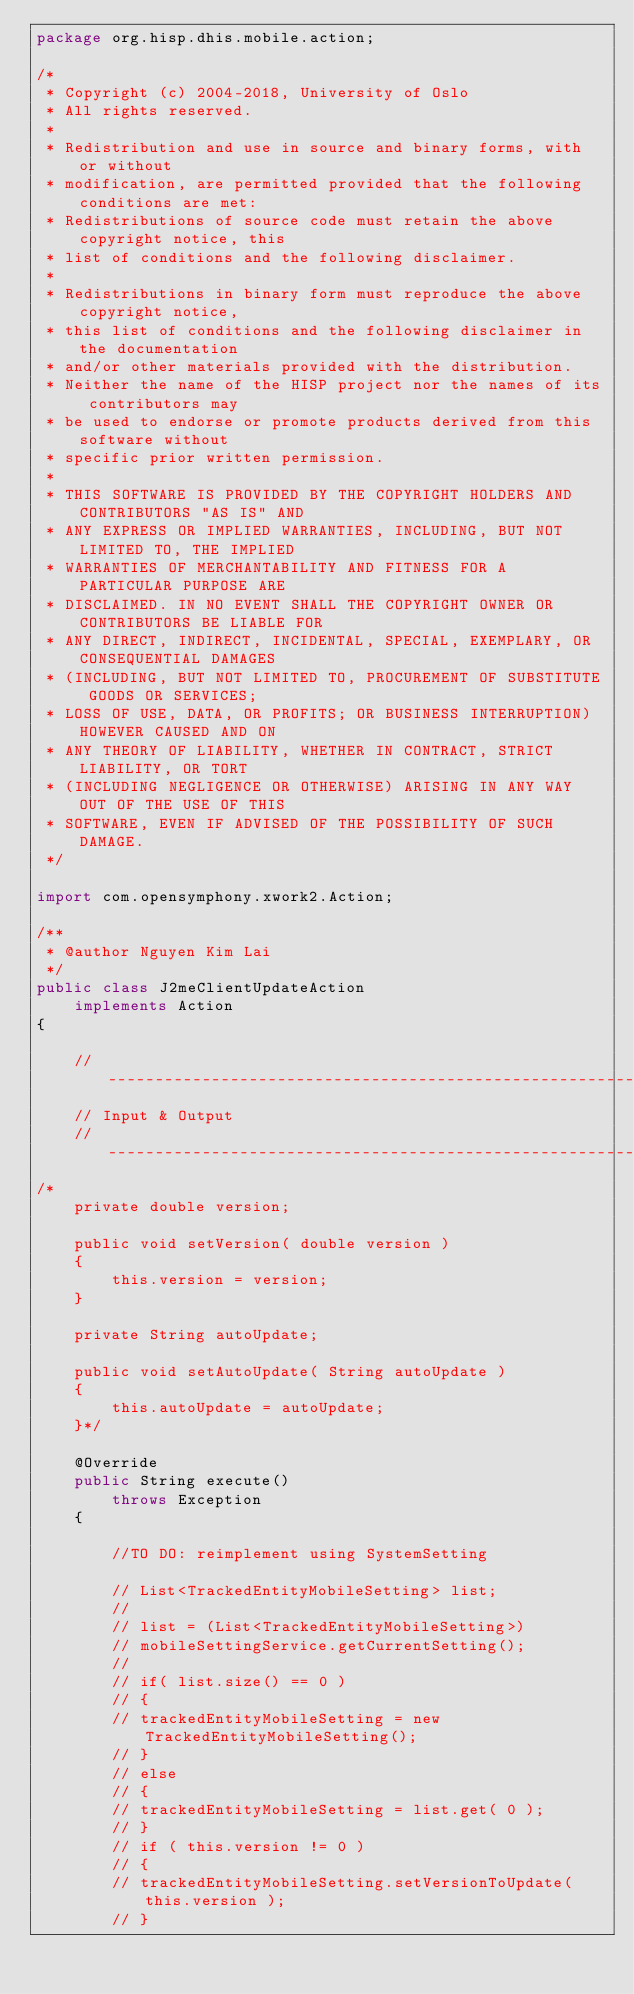Convert code to text. <code><loc_0><loc_0><loc_500><loc_500><_Java_>package org.hisp.dhis.mobile.action;

/*
 * Copyright (c) 2004-2018, University of Oslo
 * All rights reserved.
 *
 * Redistribution and use in source and binary forms, with or without
 * modification, are permitted provided that the following conditions are met:
 * Redistributions of source code must retain the above copyright notice, this
 * list of conditions and the following disclaimer.
 *
 * Redistributions in binary form must reproduce the above copyright notice,
 * this list of conditions and the following disclaimer in the documentation
 * and/or other materials provided with the distribution.
 * Neither the name of the HISP project nor the names of its contributors may
 * be used to endorse or promote products derived from this software without
 * specific prior written permission.
 *
 * THIS SOFTWARE IS PROVIDED BY THE COPYRIGHT HOLDERS AND CONTRIBUTORS "AS IS" AND
 * ANY EXPRESS OR IMPLIED WARRANTIES, INCLUDING, BUT NOT LIMITED TO, THE IMPLIED
 * WARRANTIES OF MERCHANTABILITY AND FITNESS FOR A PARTICULAR PURPOSE ARE
 * DISCLAIMED. IN NO EVENT SHALL THE COPYRIGHT OWNER OR CONTRIBUTORS BE LIABLE FOR
 * ANY DIRECT, INDIRECT, INCIDENTAL, SPECIAL, EXEMPLARY, OR CONSEQUENTIAL DAMAGES
 * (INCLUDING, BUT NOT LIMITED TO, PROCUREMENT OF SUBSTITUTE GOODS OR SERVICES;
 * LOSS OF USE, DATA, OR PROFITS; OR BUSINESS INTERRUPTION) HOWEVER CAUSED AND ON
 * ANY THEORY OF LIABILITY, WHETHER IN CONTRACT, STRICT LIABILITY, OR TORT
 * (INCLUDING NEGLIGENCE OR OTHERWISE) ARISING IN ANY WAY OUT OF THE USE OF THIS
 * SOFTWARE, EVEN IF ADVISED OF THE POSSIBILITY OF SUCH DAMAGE.
 */

import com.opensymphony.xwork2.Action;

/**
 * @author Nguyen Kim Lai
 */
public class J2meClientUpdateAction
    implements Action
{

    // -------------------------------------------------------------------------
    // Input & Output
    // -------------------------------------------------------------------------
/*
    private double version;

    public void setVersion( double version )
    {
        this.version = version;
    }

    private String autoUpdate;

    public void setAutoUpdate( String autoUpdate )
    {
        this.autoUpdate = autoUpdate;
    }*/

    @Override
    public String execute()
        throws Exception
    {

        //TO DO: reimplement using SystemSetting
        
        // List<TrackedEntityMobileSetting> list;
        //
        // list = (List<TrackedEntityMobileSetting>)
        // mobileSettingService.getCurrentSetting();
        //
        // if( list.size() == 0 )
        // {
        // trackedEntityMobileSetting = new TrackedEntityMobileSetting();
        // }
        // else
        // {
        // trackedEntityMobileSetting = list.get( 0 );
        // }
        // if ( this.version != 0 )
        // {
        // trackedEntityMobileSetting.setVersionToUpdate( this.version );
        // }</code> 